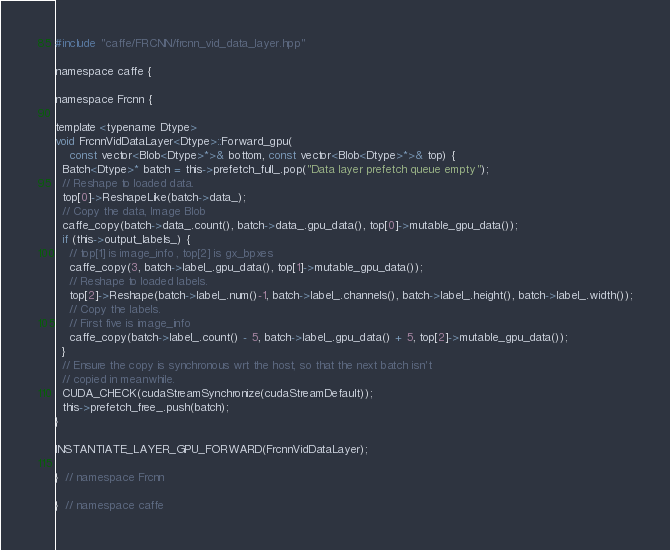<code> <loc_0><loc_0><loc_500><loc_500><_Cuda_>#include "caffe/FRCNN/frcnn_vid_data_layer.hpp"

namespace caffe {

namespace Frcnn {

template <typename Dtype>
void FrcnnVidDataLayer<Dtype>::Forward_gpu(
    const vector<Blob<Dtype>*>& bottom, const vector<Blob<Dtype>*>& top) {
  Batch<Dtype>* batch = this->prefetch_full_.pop("Data layer prefetch queue empty");
  // Reshape to loaded data.
  top[0]->ReshapeLike(batch->data_);
  // Copy the data, Image Blob
  caffe_copy(batch->data_.count(), batch->data_.gpu_data(), top[0]->mutable_gpu_data());
  if (this->output_labels_) {
    // top[1] is image_info , top[2] is gx_bpxes
    caffe_copy(3, batch->label_.gpu_data(), top[1]->mutable_gpu_data());
    // Reshape to loaded labels.
    top[2]->Reshape(batch->label_.num()-1, batch->label_.channels(), batch->label_.height(), batch->label_.width());
    // Copy the labels.
    // First five is image_info
    caffe_copy(batch->label_.count() - 5, batch->label_.gpu_data() + 5, top[2]->mutable_gpu_data());
  }
  // Ensure the copy is synchronous wrt the host, so that the next batch isn't
  // copied in meanwhile.
  CUDA_CHECK(cudaStreamSynchronize(cudaStreamDefault));
  this->prefetch_free_.push(batch);
}

INSTANTIATE_LAYER_GPU_FORWARD(FrcnnVidDataLayer);

}  // namespace Frcnn

}  // namespace caffe
</code> 